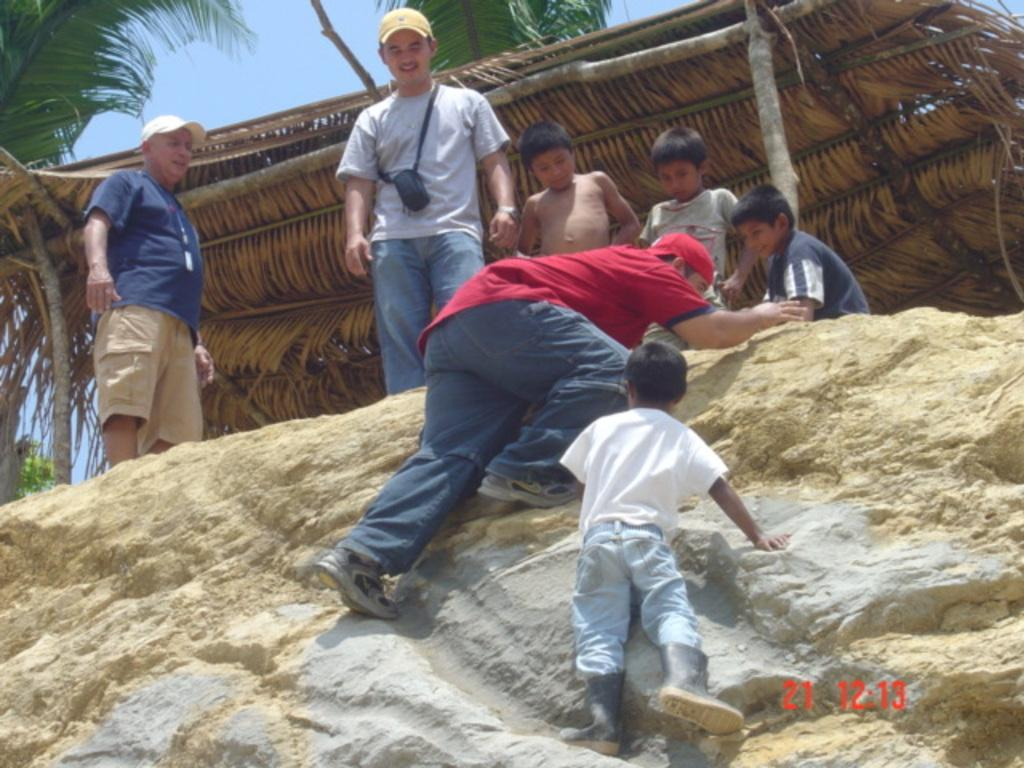What are the persons in the image doing? There are persons standing on the ground and climbing a rock in the image. What can be seen in the background of the image? There is a hut, trees, and the sky visible in the background. How many persons are visible in the image? The number of persons is not specified, but there are at least two (one standing and one climbing). What type of fog can be seen around the persons in the image? There is no fog present in the image; the sky is visible in the background. 